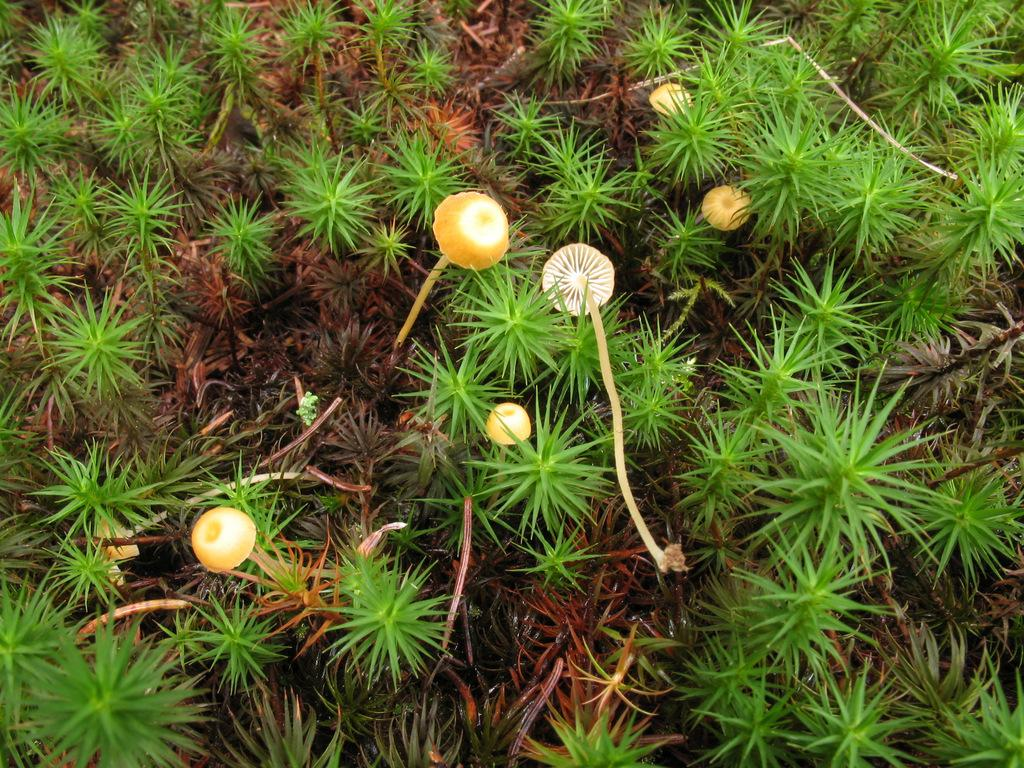What type of living organisms can be seen in the image? Plants and mushrooms can be seen in the image. What type of bells can be heard ringing during the feast in the image? There is no feast or bells present in the image; it features plants and mushrooms. 